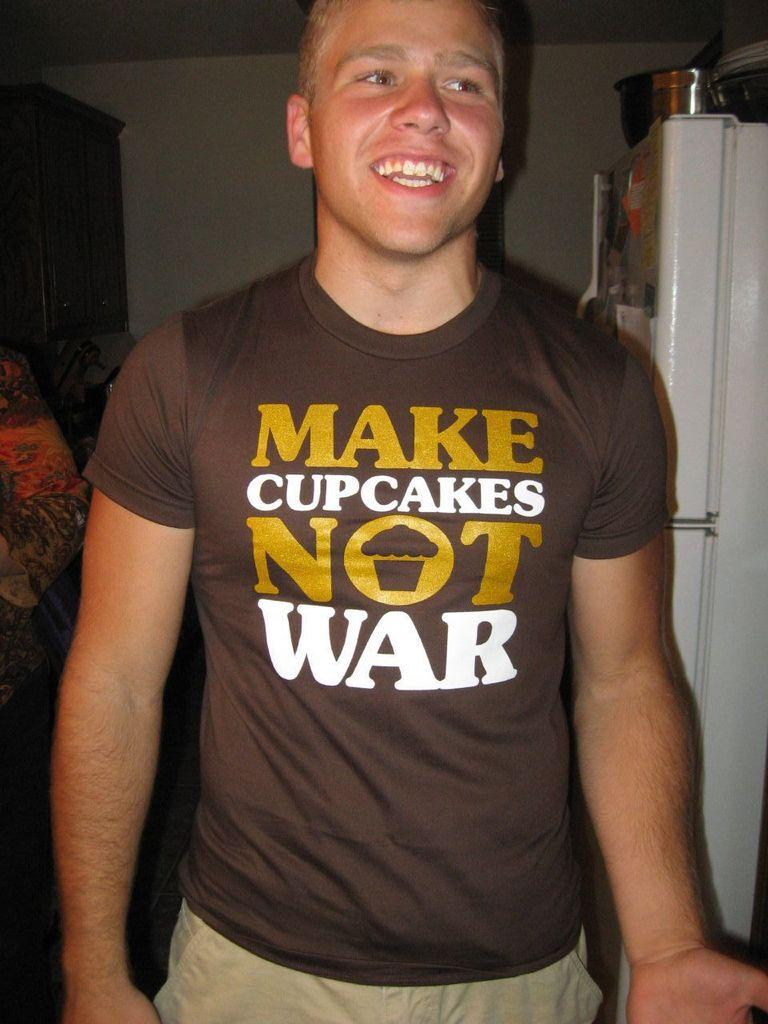<image>
Give a short and clear explanation of the subsequent image. A young man smiling and wearing a tight brown shirt which reads Make cupcakes and not war. 